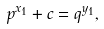<formula> <loc_0><loc_0><loc_500><loc_500>p ^ { x _ { 1 } } + c = q ^ { y _ { 1 } } ,</formula> 